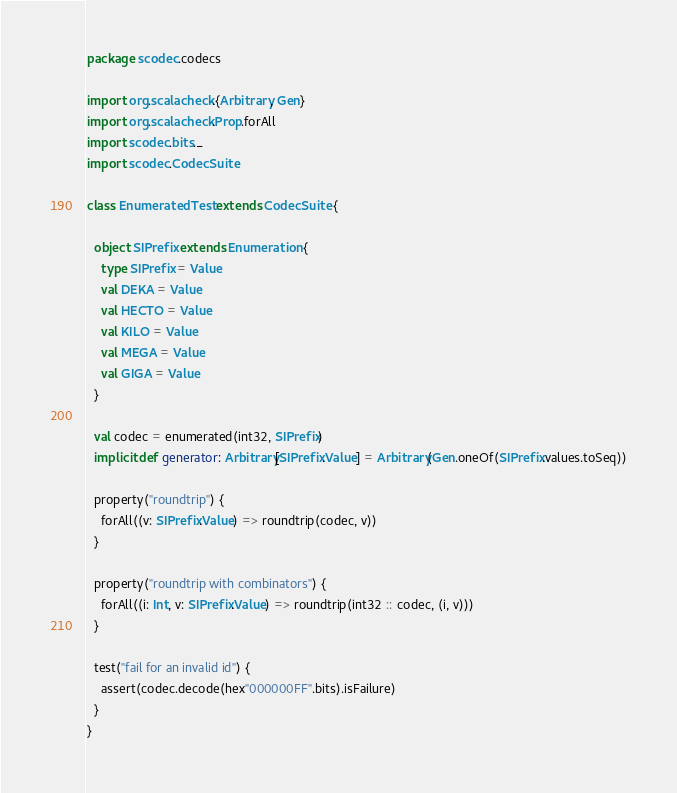Convert code to text. <code><loc_0><loc_0><loc_500><loc_500><_Scala_>package scodec.codecs

import org.scalacheck.{Arbitrary, Gen}
import org.scalacheck.Prop.forAll
import scodec.bits._
import scodec.CodecSuite

class EnumeratedTest extends CodecSuite {

  object SIPrefix extends Enumeration {
    type SIPrefix = Value
    val DEKA = Value
    val HECTO = Value
    val KILO = Value
    val MEGA = Value
    val GIGA = Value
  }

  val codec = enumerated(int32, SIPrefix)
  implicit def generator: Arbitrary[SIPrefix.Value] = Arbitrary(Gen.oneOf(SIPrefix.values.toSeq))

  property("roundtrip") {
    forAll((v: SIPrefix.Value) => roundtrip(codec, v))
  }

  property("roundtrip with combinators") {
    forAll((i: Int, v: SIPrefix.Value) => roundtrip(int32 :: codec, (i, v)))
  }

  test("fail for an invalid id") {
    assert(codec.decode(hex"000000FF".bits).isFailure)
  }
}
</code> 